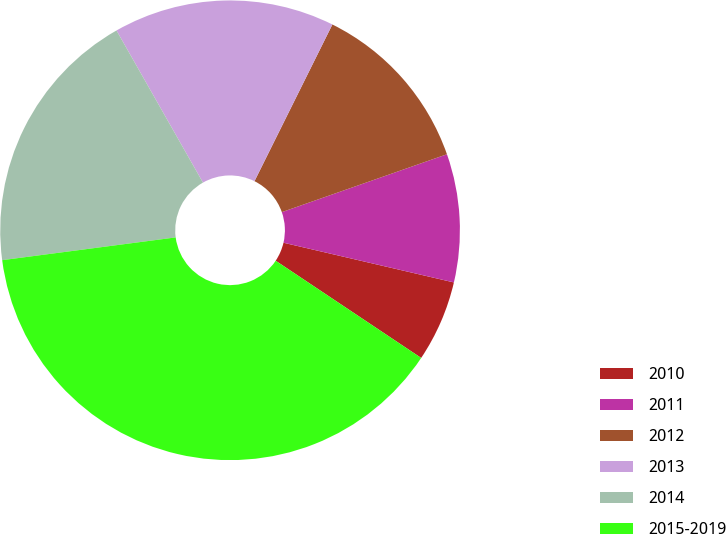<chart> <loc_0><loc_0><loc_500><loc_500><pie_chart><fcel>2010<fcel>2011<fcel>2012<fcel>2013<fcel>2014<fcel>2015-2019<nl><fcel>5.73%<fcel>9.01%<fcel>12.29%<fcel>15.57%<fcel>18.85%<fcel>38.55%<nl></chart> 